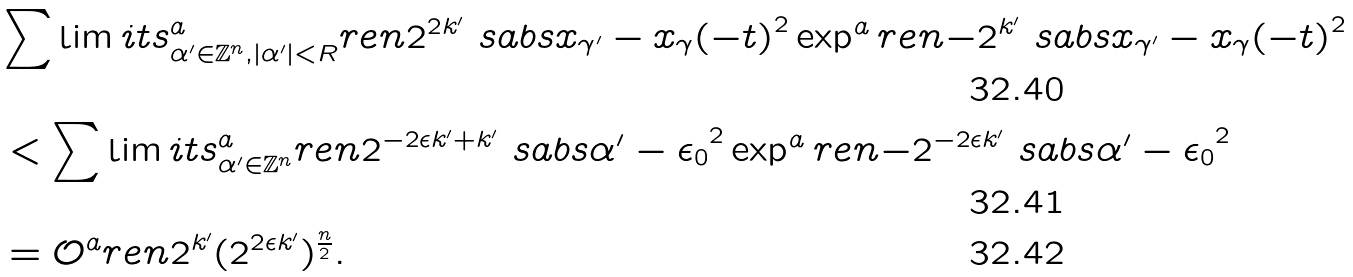<formula> <loc_0><loc_0><loc_500><loc_500>& \sum \lim i t s _ { \alpha ^ { \prime } \in \mathbb { Z } ^ { n } , | \alpha ^ { \prime } | < R } ^ { a } r e n { 2 ^ { 2 k ^ { \prime } } \ s a b s { x _ { \gamma ^ { \prime } } - x _ { \gamma } ( - t ) } ^ { 2 } } \exp ^ { a } r e n { - 2 ^ { k ^ { \prime } } \ s a b s { x _ { \gamma ^ { \prime } } - x _ { \gamma } ( - t ) } ^ { 2 } } \\ & < \sum \lim i t s _ { \alpha ^ { \prime } \in \mathbb { Z } ^ { n } } ^ { a } r e n { 2 ^ { - 2 \epsilon k ^ { \prime } + k ^ { \prime } } \ s a b s { \alpha ^ { \prime } - \epsilon _ { 0 } } ^ { 2 } } \exp ^ { a } r e n { - 2 ^ { - 2 \epsilon k ^ { \prime } } \ s a b s { \alpha ^ { \prime } - \epsilon _ { 0 } } ^ { 2 } } \\ & = \mathcal { O } ^ { a } r e n { 2 ^ { k ^ { \prime } } ( 2 ^ { 2 \epsilon k ^ { \prime } } ) ^ { \frac { n } { 2 } } } .</formula> 